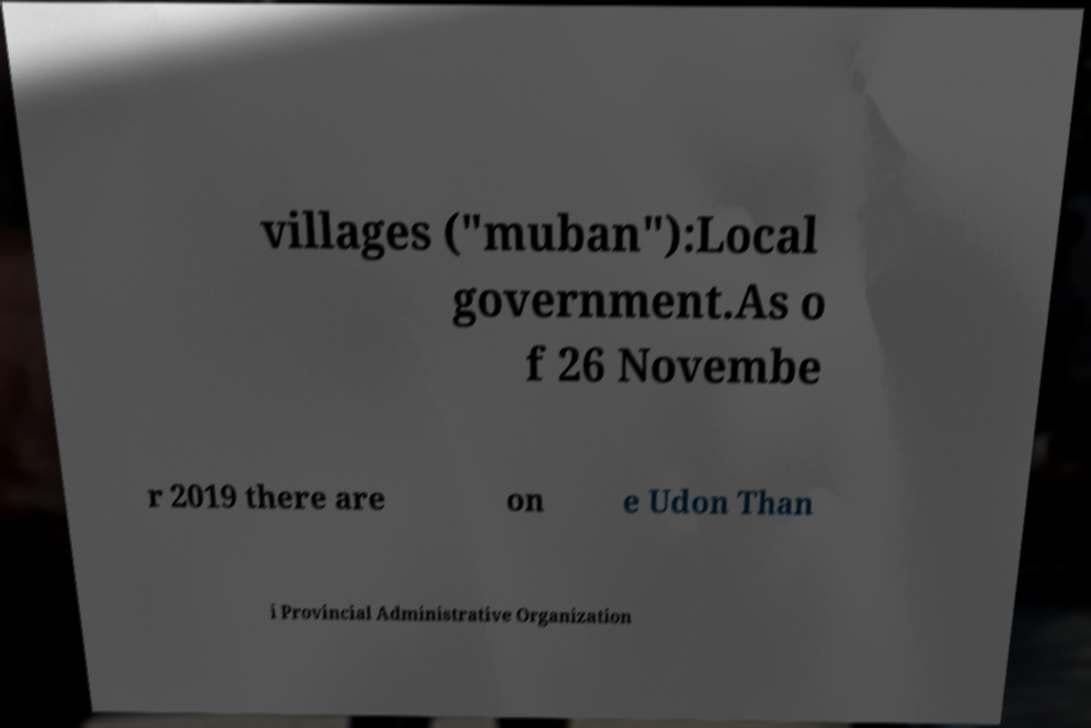For documentation purposes, I need the text within this image transcribed. Could you provide that? villages ("muban"):Local government.As o f 26 Novembe r 2019 there are on e Udon Than i Provincial Administrative Organization 